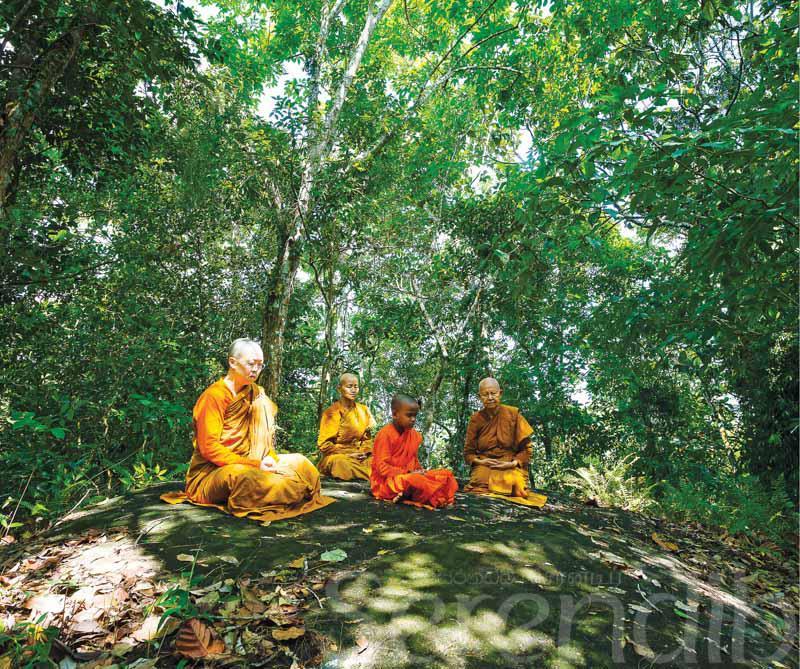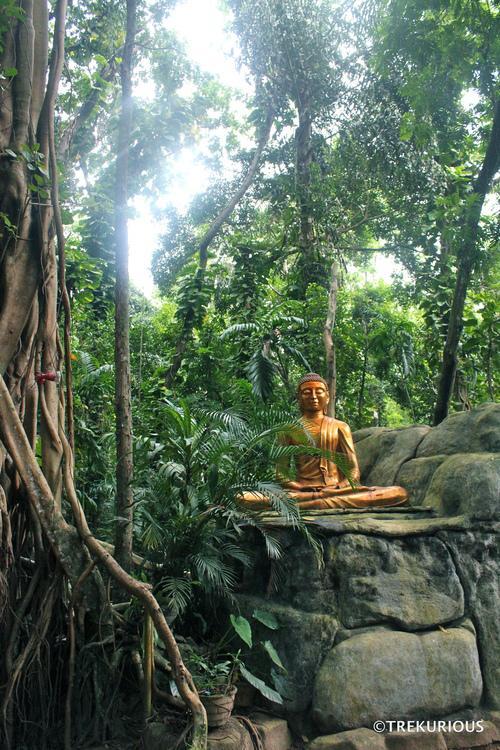The first image is the image on the left, the second image is the image on the right. Considering the images on both sides, is "In the right image, a figure is sitting in a lotus position on an elevated platform surrounded by foliage and curving vines." valid? Answer yes or no. Yes. The first image is the image on the left, the second image is the image on the right. Considering the images on both sides, is "In at least one image there is a single monk walking away into a forest." valid? Answer yes or no. No. 